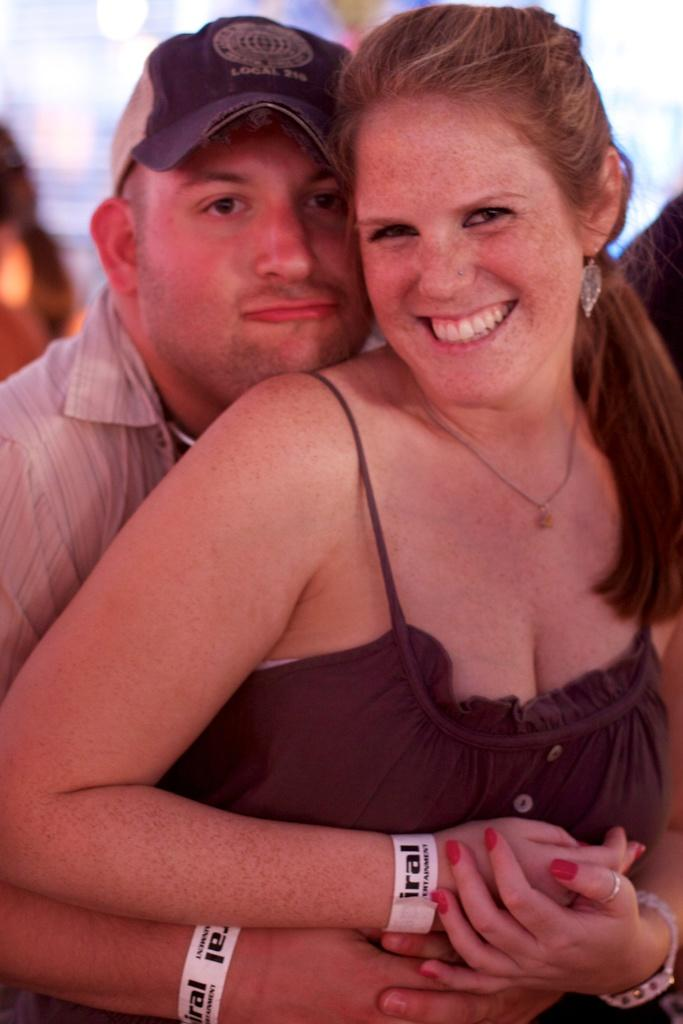What is the man doing in the image? The man is hugging a woman with his hands. What is the woman's role in the image? The woman is being hugged by the man. Can you describe the setting of the image? The image does not provide information about the setting. What is the relationship between the man and the woman? The image does not provide information about their relationship. What type of produce can be seen growing on the island in the image? There is no island or produce present in the image. --- Transcript: In this picture we can see a cat sitting on a chair. The cat is looking at something. Facts: 1. There is a cat in the picture. 2. The cat is sitting on a chair. 3. The cat is looking at something. Absurd Topics: bird, ocean, sand Conversation: What animal is in the picture? There is a cat in the picture. What is the cat doing in the picture? The cat is sitting on a chair. What is the cat looking at in the picture? The cat is looking at something. Can you describe the cat's appearance? The image does not provide information about the cat's appearance. Reasoning: Let's think step by step in order to produce the conversation. We start by identifying the main subject in the image, which is the cat. Then, we describe the cat's actions and position, noting that it is sitting on a chair and looking at something. We avoid making assumptions about the cat's appearance, as the provided facts do not give any information about this aspect. Absurd Question/Answer: What type of bird can be seen flying over the ocean in the image? There is no bird or ocean present in the image. --- Transcript: In this image we can see a person holding a camera. The person is standing in front of a building. Facts: 1. There is a person in the image. 2. The person is holding a camera. 3. The person is standing in front of a building. Absurd Topics: dance, music, stage Conversation: Who is in the image? There is a person in the image. What is the person doing in the image? The person is holding a camera. What is behind the person in the image? The person is standing in front of a building. Can you describe the building in the image? The image does not provide information about the building's appearance. Reasoning: Let's think step by step in order to produce the conversation. We start by identifying the main subject in the image, which is the person. Then, we describe the person's actions and position, noting that they are holding a camera and standing in front of a building. We avoid making assumptions 